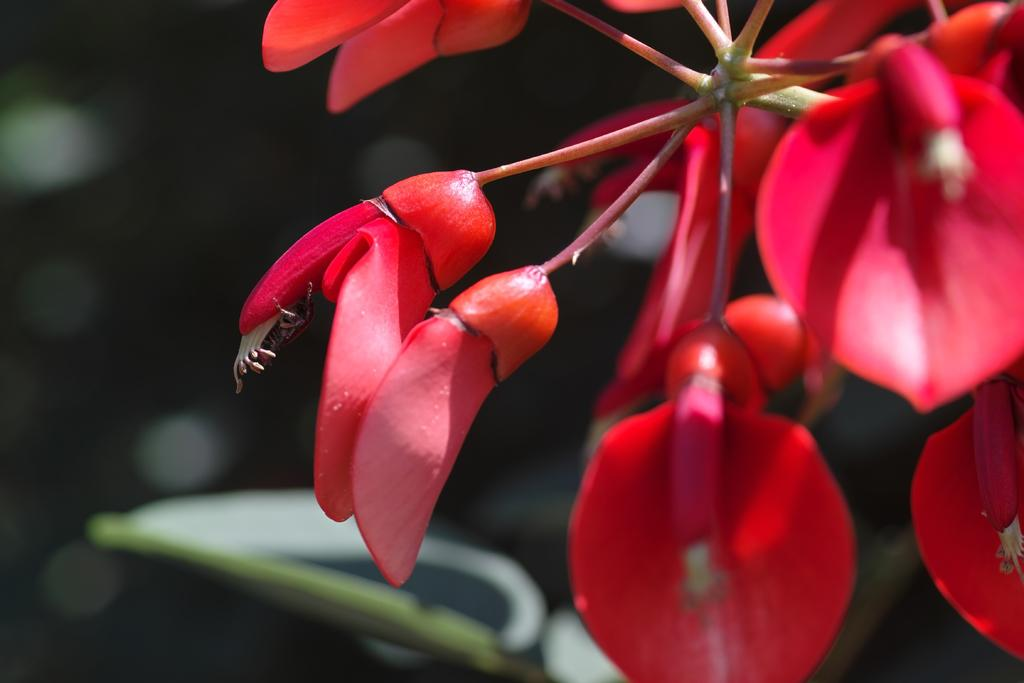What is present in the image? There is a plant in the image. What specific feature of the plant can be observed? The plant has flowers. What color are the flowers? The flowers are red. What can be seen in the background of the image? The background of the image contains plants. How is the background of the image depicted? The background is blurred. What year is depicted in the image? There is no specific year depicted in the image; it features a plant with red flowers and a blurred background. How much sugar is present in the image? There is no sugar present in the image; it features a plant with red flowers and a blurred background. 